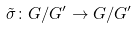<formula> <loc_0><loc_0><loc_500><loc_500>\tilde { \sigma } \colon G / G ^ { \prime } \rightarrow G / G ^ { \prime }</formula> 